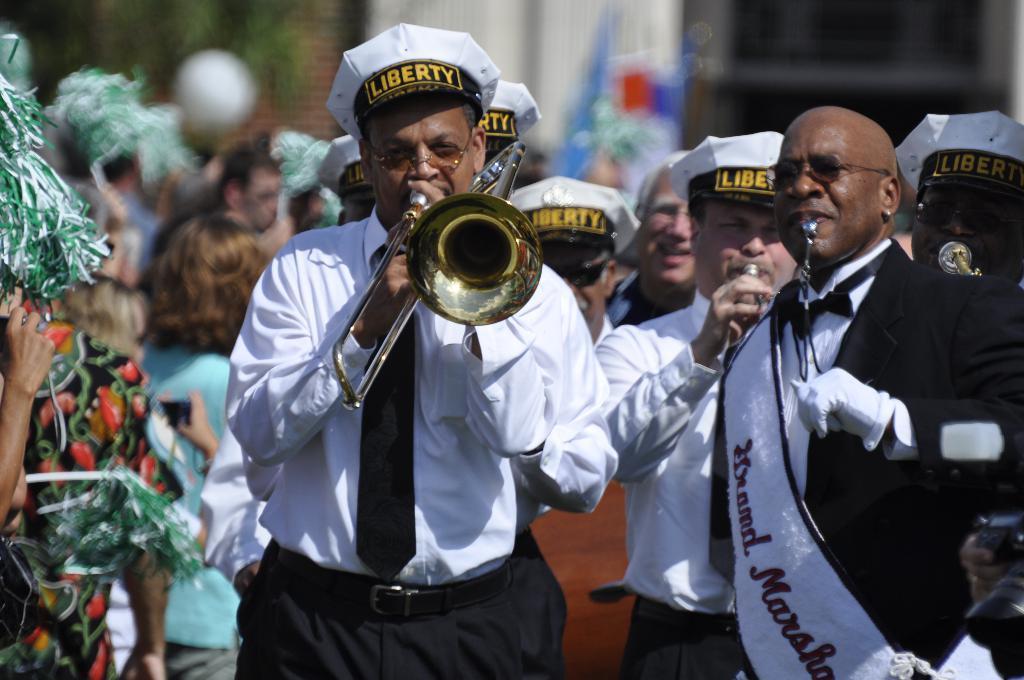How would you summarize this image in a sentence or two? In this picture I can see few people among them few people are playing musical instruments. 